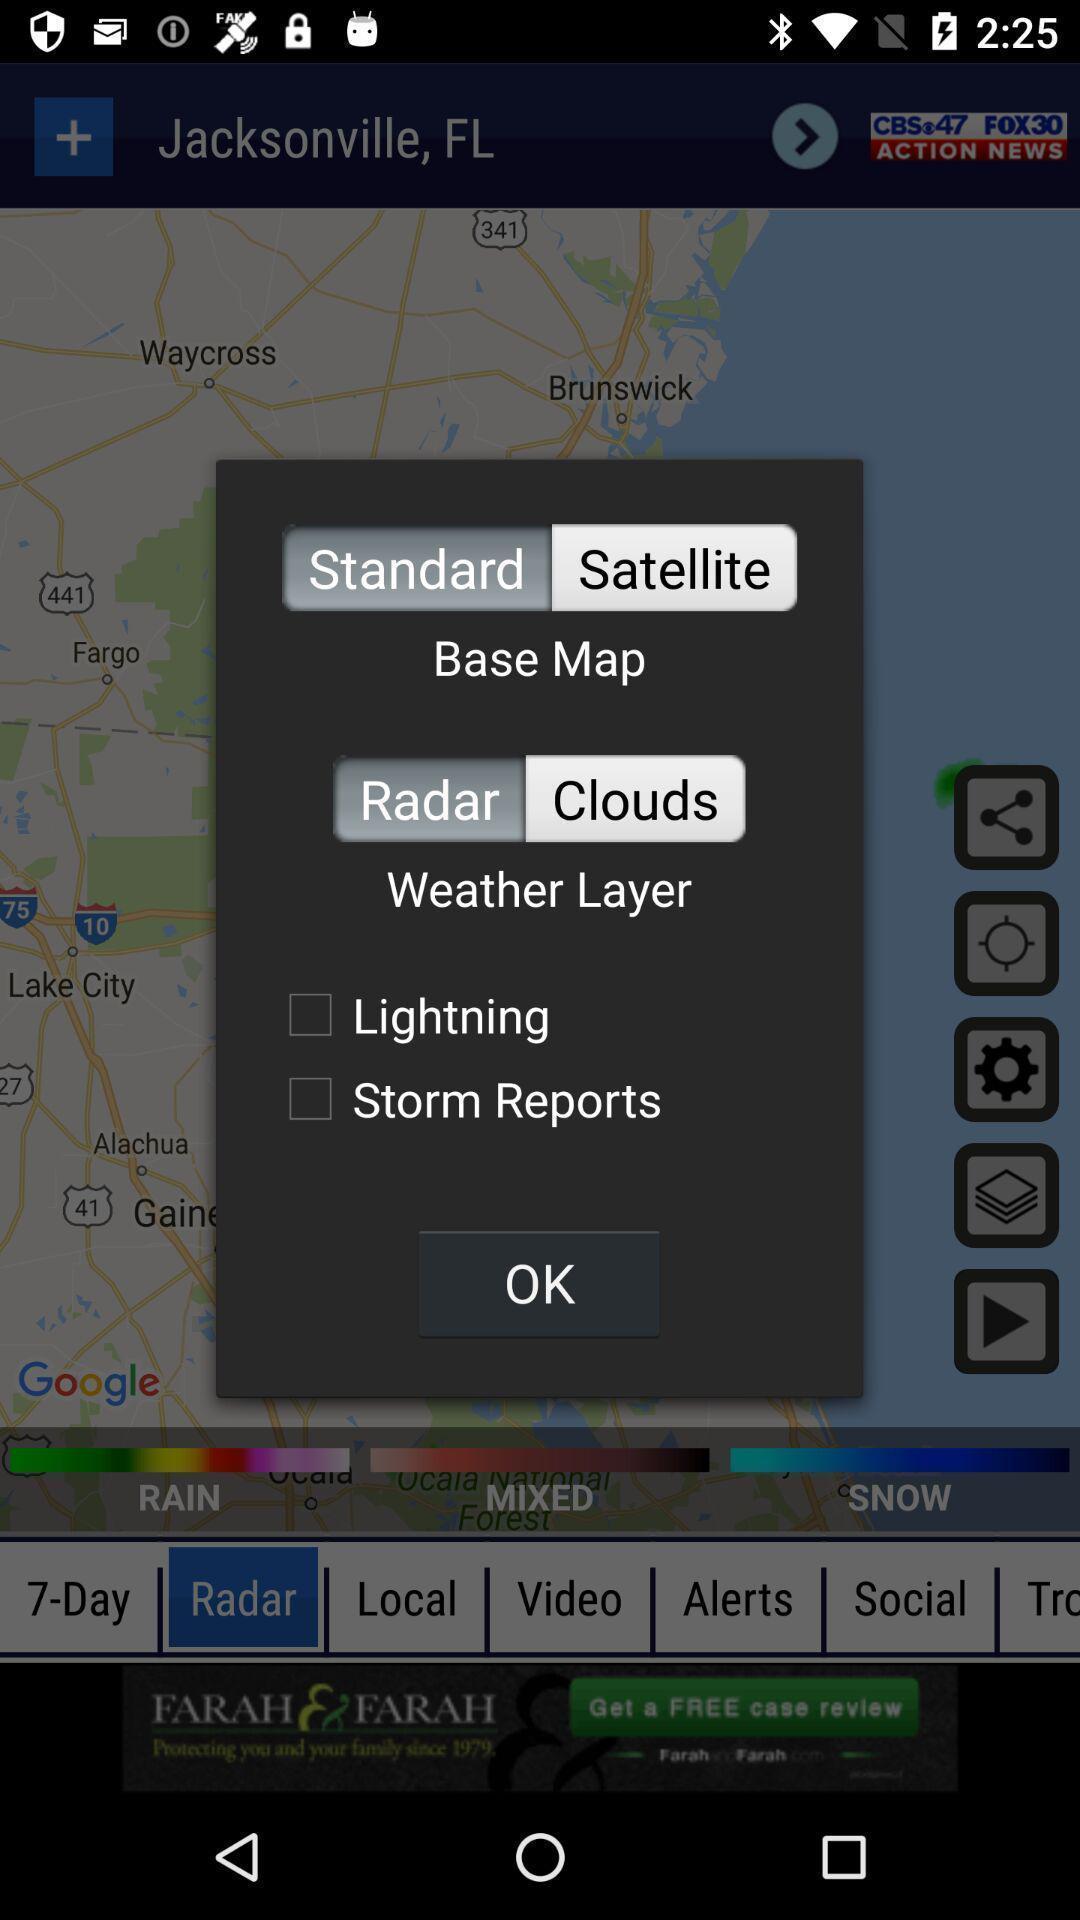Describe the content in this image. Pop-up shows weather alerts. 